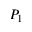Convert formula to latex. <formula><loc_0><loc_0><loc_500><loc_500>P _ { 1 }</formula> 